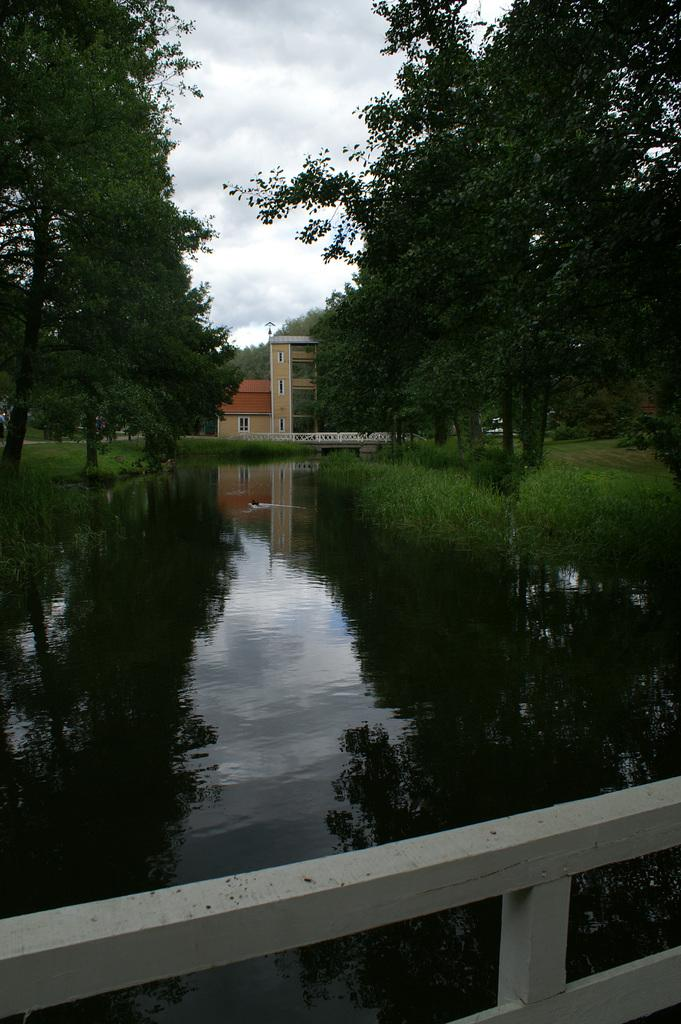What can be seen in the left corner of the image? There are trees in the left corner of the image. What can be seen in the right corner of the image? There are trees in the right corner of the image. What is located at the bottom of the image? There is water at the bottom of the image. What is visible in the background of the image? There are buildings and trees in the background of the image. What is visible at the top of the image? The sky is visible at the top of the image. What type of industry is depicted in the image? There is no specific industry depicted in the image; it primarily features trees, water, buildings, and the sky. What statement can be made about the pocket in the image? There is no pocket present in the image. 